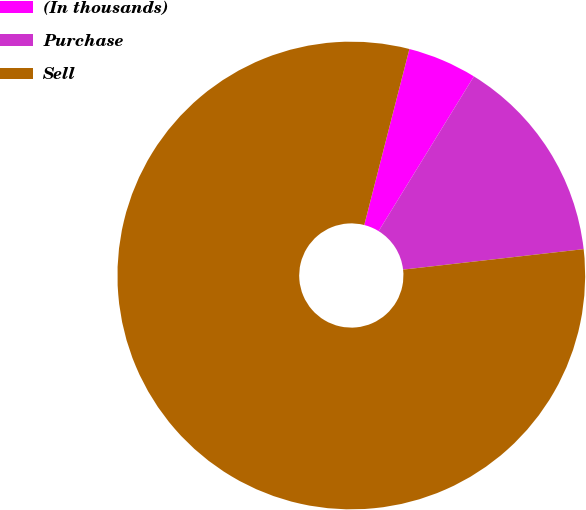Convert chart. <chart><loc_0><loc_0><loc_500><loc_500><pie_chart><fcel>(In thousands)<fcel>Purchase<fcel>Sell<nl><fcel>4.79%<fcel>14.42%<fcel>80.8%<nl></chart> 